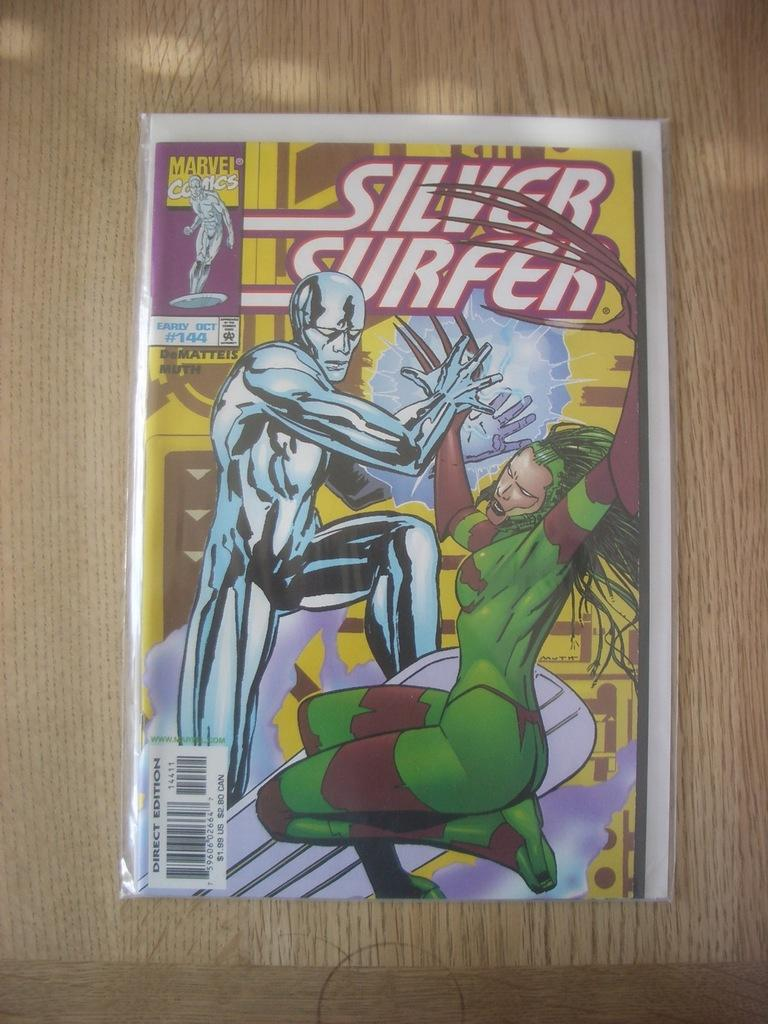What is depicted on the paper in the image? There is a paper with animated pictures in the image. Can you identify any additional features on the paper? Yes, the paper has a barcode. Where is the paper located in the image? The paper is placed on a table. How many sticks are used to perform the trick in the image? There are no sticks or tricks present in the image; it features a paper with animated pictures and a barcode. 